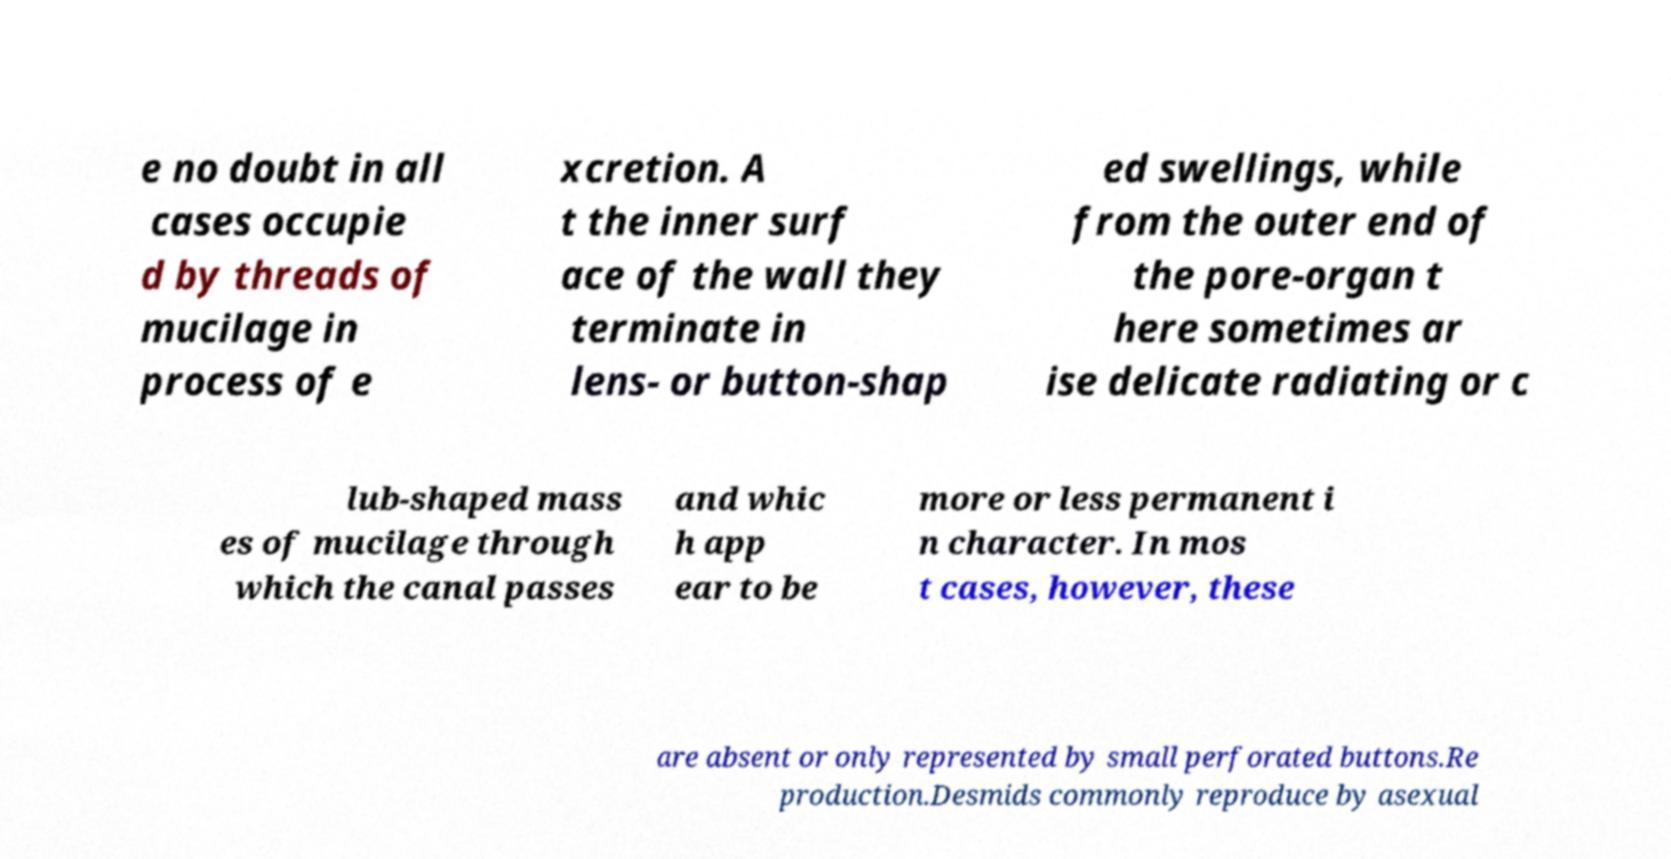What messages or text are displayed in this image? I need them in a readable, typed format. e no doubt in all cases occupie d by threads of mucilage in process of e xcretion. A t the inner surf ace of the wall they terminate in lens- or button-shap ed swellings, while from the outer end of the pore-organ t here sometimes ar ise delicate radiating or c lub-shaped mass es of mucilage through which the canal passes and whic h app ear to be more or less permanent i n character. In mos t cases, however, these are absent or only represented by small perforated buttons.Re production.Desmids commonly reproduce by asexual 